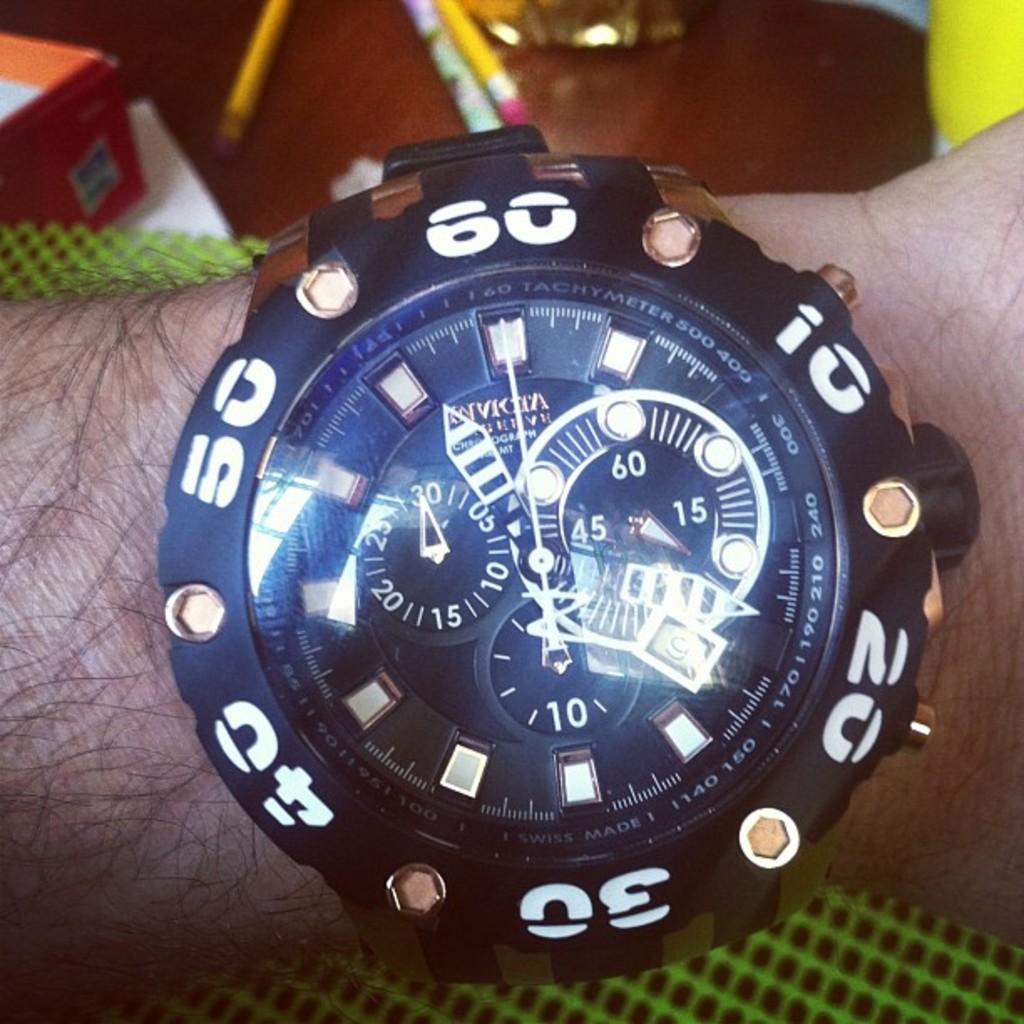Provide a one-sentence caption for the provided image. An Invicta branded watch in black with white numbers shown on someone's wrist. 